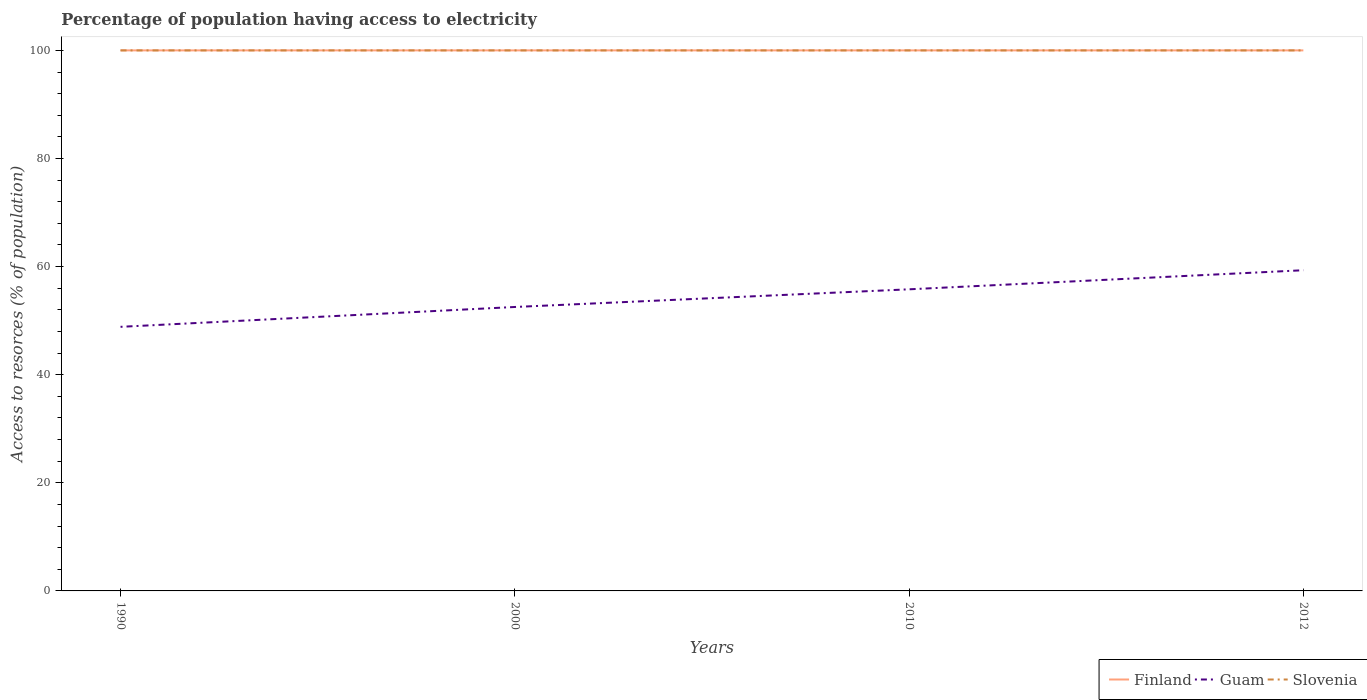Is the number of lines equal to the number of legend labels?
Offer a terse response. Yes. Across all years, what is the maximum percentage of population having access to electricity in Finland?
Ensure brevity in your answer.  100. What is the difference between the highest and the second highest percentage of population having access to electricity in Slovenia?
Keep it short and to the point. 0. What is the difference between the highest and the lowest percentage of population having access to electricity in Guam?
Provide a short and direct response. 2. Is the percentage of population having access to electricity in Finland strictly greater than the percentage of population having access to electricity in Slovenia over the years?
Provide a succinct answer. No. How many years are there in the graph?
Your response must be concise. 4. Are the values on the major ticks of Y-axis written in scientific E-notation?
Your answer should be very brief. No. Where does the legend appear in the graph?
Ensure brevity in your answer.  Bottom right. What is the title of the graph?
Provide a succinct answer. Percentage of population having access to electricity. Does "Kyrgyz Republic" appear as one of the legend labels in the graph?
Offer a terse response. No. What is the label or title of the X-axis?
Provide a short and direct response. Years. What is the label or title of the Y-axis?
Ensure brevity in your answer.  Access to resorces (% of population). What is the Access to resorces (% of population) in Guam in 1990?
Ensure brevity in your answer.  48.86. What is the Access to resorces (% of population) in Guam in 2000?
Give a very brief answer. 52.53. What is the Access to resorces (% of population) in Slovenia in 2000?
Your answer should be compact. 100. What is the Access to resorces (% of population) of Finland in 2010?
Give a very brief answer. 100. What is the Access to resorces (% of population) in Guam in 2010?
Ensure brevity in your answer.  55.8. What is the Access to resorces (% of population) in Slovenia in 2010?
Make the answer very short. 100. What is the Access to resorces (% of population) of Finland in 2012?
Your answer should be compact. 100. What is the Access to resorces (% of population) of Guam in 2012?
Your answer should be compact. 59.33. What is the Access to resorces (% of population) of Slovenia in 2012?
Keep it short and to the point. 100. Across all years, what is the maximum Access to resorces (% of population) in Guam?
Your answer should be compact. 59.33. Across all years, what is the minimum Access to resorces (% of population) in Guam?
Keep it short and to the point. 48.86. Across all years, what is the minimum Access to resorces (% of population) of Slovenia?
Keep it short and to the point. 100. What is the total Access to resorces (% of population) in Guam in the graph?
Provide a short and direct response. 216.52. What is the total Access to resorces (% of population) of Slovenia in the graph?
Your answer should be very brief. 400. What is the difference between the Access to resorces (% of population) of Finland in 1990 and that in 2000?
Your answer should be very brief. 0. What is the difference between the Access to resorces (% of population) in Guam in 1990 and that in 2000?
Offer a very short reply. -3.67. What is the difference between the Access to resorces (% of population) in Slovenia in 1990 and that in 2000?
Provide a succinct answer. 0. What is the difference between the Access to resorces (% of population) of Finland in 1990 and that in 2010?
Offer a terse response. 0. What is the difference between the Access to resorces (% of population) in Guam in 1990 and that in 2010?
Ensure brevity in your answer.  -6.94. What is the difference between the Access to resorces (% of population) of Guam in 1990 and that in 2012?
Your answer should be very brief. -10.47. What is the difference between the Access to resorces (% of population) of Slovenia in 1990 and that in 2012?
Keep it short and to the point. 0. What is the difference between the Access to resorces (% of population) in Guam in 2000 and that in 2010?
Give a very brief answer. -3.27. What is the difference between the Access to resorces (% of population) of Finland in 2000 and that in 2012?
Ensure brevity in your answer.  0. What is the difference between the Access to resorces (% of population) of Guam in 2000 and that in 2012?
Make the answer very short. -6.8. What is the difference between the Access to resorces (% of population) in Finland in 2010 and that in 2012?
Your answer should be compact. 0. What is the difference between the Access to resorces (% of population) of Guam in 2010 and that in 2012?
Make the answer very short. -3.53. What is the difference between the Access to resorces (% of population) of Slovenia in 2010 and that in 2012?
Give a very brief answer. 0. What is the difference between the Access to resorces (% of population) of Finland in 1990 and the Access to resorces (% of population) of Guam in 2000?
Ensure brevity in your answer.  47.47. What is the difference between the Access to resorces (% of population) in Finland in 1990 and the Access to resorces (% of population) in Slovenia in 2000?
Give a very brief answer. 0. What is the difference between the Access to resorces (% of population) in Guam in 1990 and the Access to resorces (% of population) in Slovenia in 2000?
Keep it short and to the point. -51.14. What is the difference between the Access to resorces (% of population) of Finland in 1990 and the Access to resorces (% of population) of Guam in 2010?
Your response must be concise. 44.2. What is the difference between the Access to resorces (% of population) in Guam in 1990 and the Access to resorces (% of population) in Slovenia in 2010?
Give a very brief answer. -51.14. What is the difference between the Access to resorces (% of population) of Finland in 1990 and the Access to resorces (% of population) of Guam in 2012?
Give a very brief answer. 40.67. What is the difference between the Access to resorces (% of population) in Guam in 1990 and the Access to resorces (% of population) in Slovenia in 2012?
Give a very brief answer. -51.14. What is the difference between the Access to resorces (% of population) in Finland in 2000 and the Access to resorces (% of population) in Guam in 2010?
Ensure brevity in your answer.  44.2. What is the difference between the Access to resorces (% of population) in Finland in 2000 and the Access to resorces (% of population) in Slovenia in 2010?
Ensure brevity in your answer.  0. What is the difference between the Access to resorces (% of population) of Guam in 2000 and the Access to resorces (% of population) of Slovenia in 2010?
Make the answer very short. -47.47. What is the difference between the Access to resorces (% of population) of Finland in 2000 and the Access to resorces (% of population) of Guam in 2012?
Offer a very short reply. 40.67. What is the difference between the Access to resorces (% of population) of Finland in 2000 and the Access to resorces (% of population) of Slovenia in 2012?
Ensure brevity in your answer.  0. What is the difference between the Access to resorces (% of population) of Guam in 2000 and the Access to resorces (% of population) of Slovenia in 2012?
Give a very brief answer. -47.47. What is the difference between the Access to resorces (% of population) in Finland in 2010 and the Access to resorces (% of population) in Guam in 2012?
Keep it short and to the point. 40.67. What is the difference between the Access to resorces (% of population) in Guam in 2010 and the Access to resorces (% of population) in Slovenia in 2012?
Offer a very short reply. -44.2. What is the average Access to resorces (% of population) of Guam per year?
Offer a very short reply. 54.13. In the year 1990, what is the difference between the Access to resorces (% of population) in Finland and Access to resorces (% of population) in Guam?
Keep it short and to the point. 51.14. In the year 1990, what is the difference between the Access to resorces (% of population) of Finland and Access to resorces (% of population) of Slovenia?
Ensure brevity in your answer.  0. In the year 1990, what is the difference between the Access to resorces (% of population) in Guam and Access to resorces (% of population) in Slovenia?
Offer a very short reply. -51.14. In the year 2000, what is the difference between the Access to resorces (% of population) in Finland and Access to resorces (% of population) in Guam?
Provide a short and direct response. 47.47. In the year 2000, what is the difference between the Access to resorces (% of population) in Finland and Access to resorces (% of population) in Slovenia?
Your response must be concise. 0. In the year 2000, what is the difference between the Access to resorces (% of population) in Guam and Access to resorces (% of population) in Slovenia?
Give a very brief answer. -47.47. In the year 2010, what is the difference between the Access to resorces (% of population) of Finland and Access to resorces (% of population) of Guam?
Your answer should be compact. 44.2. In the year 2010, what is the difference between the Access to resorces (% of population) of Finland and Access to resorces (% of population) of Slovenia?
Provide a succinct answer. 0. In the year 2010, what is the difference between the Access to resorces (% of population) of Guam and Access to resorces (% of population) of Slovenia?
Your answer should be very brief. -44.2. In the year 2012, what is the difference between the Access to resorces (% of population) of Finland and Access to resorces (% of population) of Guam?
Your answer should be compact. 40.67. In the year 2012, what is the difference between the Access to resorces (% of population) of Finland and Access to resorces (% of population) of Slovenia?
Make the answer very short. 0. In the year 2012, what is the difference between the Access to resorces (% of population) in Guam and Access to resorces (% of population) in Slovenia?
Offer a terse response. -40.67. What is the ratio of the Access to resorces (% of population) in Guam in 1990 to that in 2000?
Ensure brevity in your answer.  0.93. What is the ratio of the Access to resorces (% of population) of Slovenia in 1990 to that in 2000?
Offer a very short reply. 1. What is the ratio of the Access to resorces (% of population) of Guam in 1990 to that in 2010?
Provide a succinct answer. 0.88. What is the ratio of the Access to resorces (% of population) in Guam in 1990 to that in 2012?
Offer a terse response. 0.82. What is the ratio of the Access to resorces (% of population) in Guam in 2000 to that in 2010?
Give a very brief answer. 0.94. What is the ratio of the Access to resorces (% of population) of Slovenia in 2000 to that in 2010?
Offer a very short reply. 1. What is the ratio of the Access to resorces (% of population) of Finland in 2000 to that in 2012?
Your answer should be compact. 1. What is the ratio of the Access to resorces (% of population) in Guam in 2000 to that in 2012?
Ensure brevity in your answer.  0.89. What is the ratio of the Access to resorces (% of population) of Guam in 2010 to that in 2012?
Provide a short and direct response. 0.94. What is the ratio of the Access to resorces (% of population) in Slovenia in 2010 to that in 2012?
Make the answer very short. 1. What is the difference between the highest and the second highest Access to resorces (% of population) in Finland?
Offer a very short reply. 0. What is the difference between the highest and the second highest Access to resorces (% of population) of Guam?
Give a very brief answer. 3.53. What is the difference between the highest and the second highest Access to resorces (% of population) of Slovenia?
Make the answer very short. 0. What is the difference between the highest and the lowest Access to resorces (% of population) of Guam?
Give a very brief answer. 10.47. 